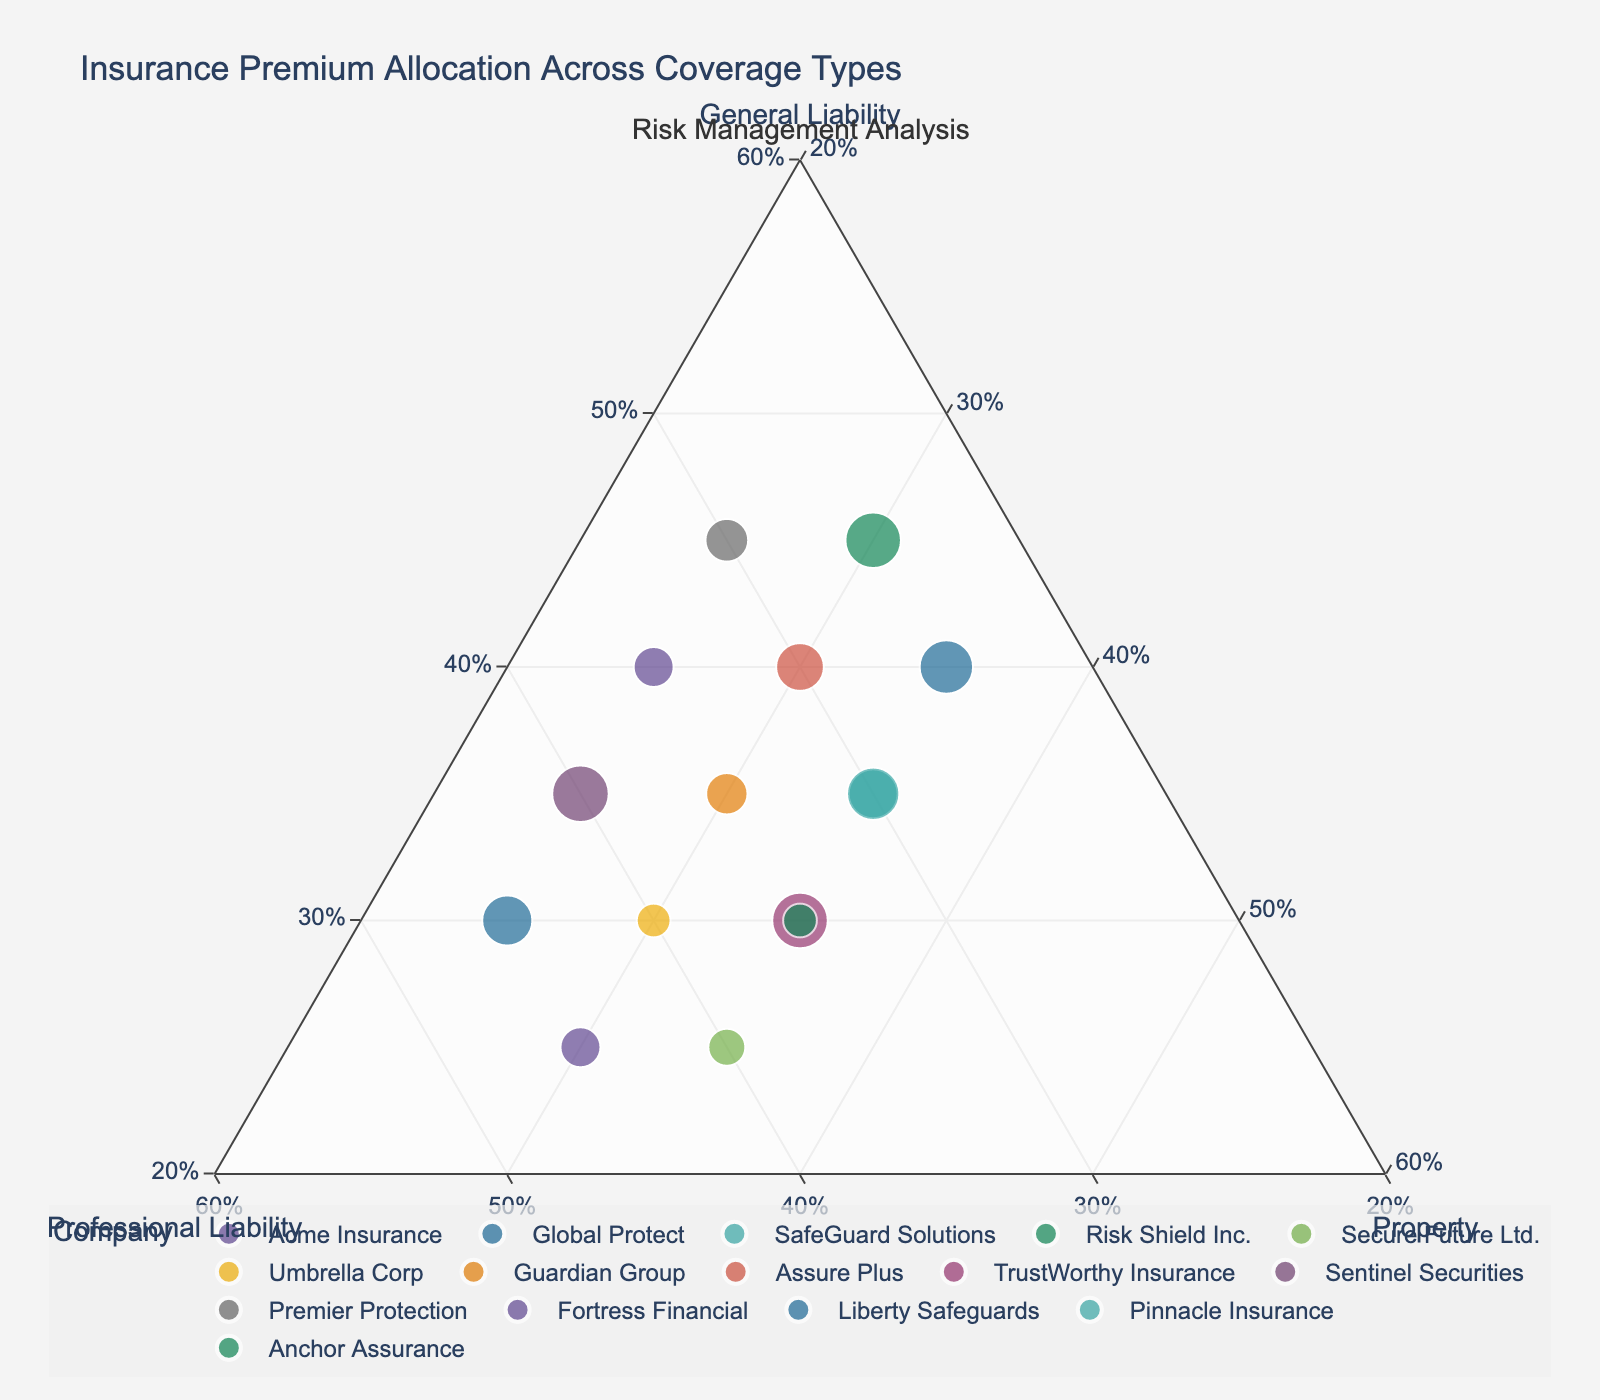What is the title of the plot? The title can be found at the top of the figure, usually in larger and bold text. In this case, it is "Insurance Premium Allocation Across Coverage Types."
Answer: Insurance Premium Allocation Across Coverage Types Which company allocates the most percentage to General Liability? Locate the point closest to the General Liability vertex on the ternary plot. Risk Shield Inc. and Premier Protection both allocate 45% to General Liability.
Answer: Risk Shield Inc. and Premier Protection Which company allocates the least percentage to Property? Find the point closest to the General Liability and Professional Liability vertices. Acme Insurance and Sentinel Securities both allocate 25% to Property.
Answer: Acme Insurance and Sentinel Securities What is the allocation of SafeGuard Solutions? Look for 'SafeGuard Solutions' on the ternary plot and read the percentages off each axis. SafeGuard Solutions allocates 35% to General Liability, 30% to Professional Liability, and 35% to Property.
Answer: 35% General Liability, 30% Professional Liability, 35% Property How many companies allocate an equal percentage to Property and Professional Liability? Search for points that are equidistant from both the Property and Professional Liability vertices. Anchor Assurance and TrustWorthy Insurance both allocate 35% to Property and Professional Liability.
Answer: 2 companies Which company has the highest combined allocation to Property and Professional Liability? Add the percentages of Property and Professional Liability for each company and find the maximum. Global Protect with 45% Professional Liability and 25% Property, totaling 70%.
Answer: Global Protect What is the average allocation for General Liability across all companies? Sum the General Liability percentages and divide by the number of companies: (40 + 30 + 35 + 45 + 25 + 30 + 35 + 40 + 30 + 35 + 45 + 25 + 40 + 35 + 30) / 15 = 34.33%.
Answer: 34.33% How does the allocation of Professional Liability for Secure Future Ltd. compare to the others? Locate Secure Future Ltd. and note its allocation of 40%. Compare this to other companies' allocations. Secure Future Ltd. has one of the higher allocations for Professional Liability.
Answer: One of the higher allocations Which company’s premium allocation is closest to equal among the three types of coverage? Look for points near the center of the ternary plot. SafeGuard Solutions and Pinnacle Insurance both have allocations close to being equal with 35% in some type of coverage.
Answer: SafeGuard Solutions and Pinnacle Insurance 